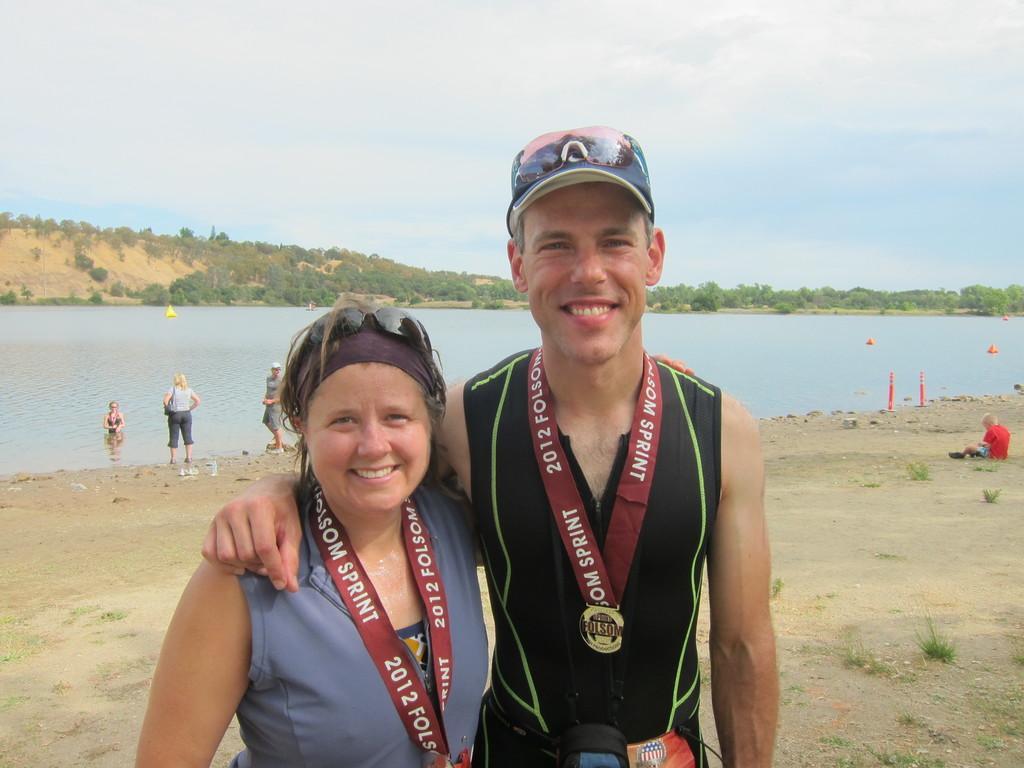Can you describe this image briefly? In this picture there are two people standing and smiling. At the back there are two persons standing on the ground and there is a person in the water and there are trees on the mountain. At the top there is sky and there are clouds. At the bottom there is water and there is ground and there are objects on the ground. On the right side of the image there is a person sitting on the ground. 